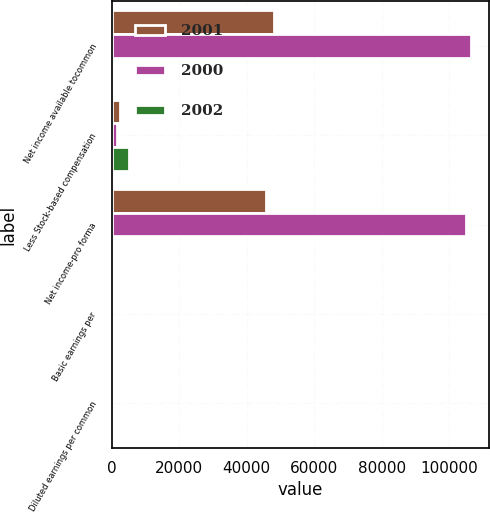<chart> <loc_0><loc_0><loc_500><loc_500><stacked_bar_chart><ecel><fcel>Net income available tocommon<fcel>Less Stock-based compensation<fcel>Net income-pro forma<fcel>Basic earnings per<fcel>Diluted earnings per common<nl><fcel>2001<fcel>48179<fcel>2315<fcel>45864<fcel>0.44<fcel>0.43<nl><fcel>2000<fcel>106418<fcel>1399<fcel>105019<fcel>0.99<fcel>0.97<nl><fcel>2002<fcel>1.32<fcel>5058<fcel>1.32<fcel>1.32<fcel>1.28<nl></chart> 